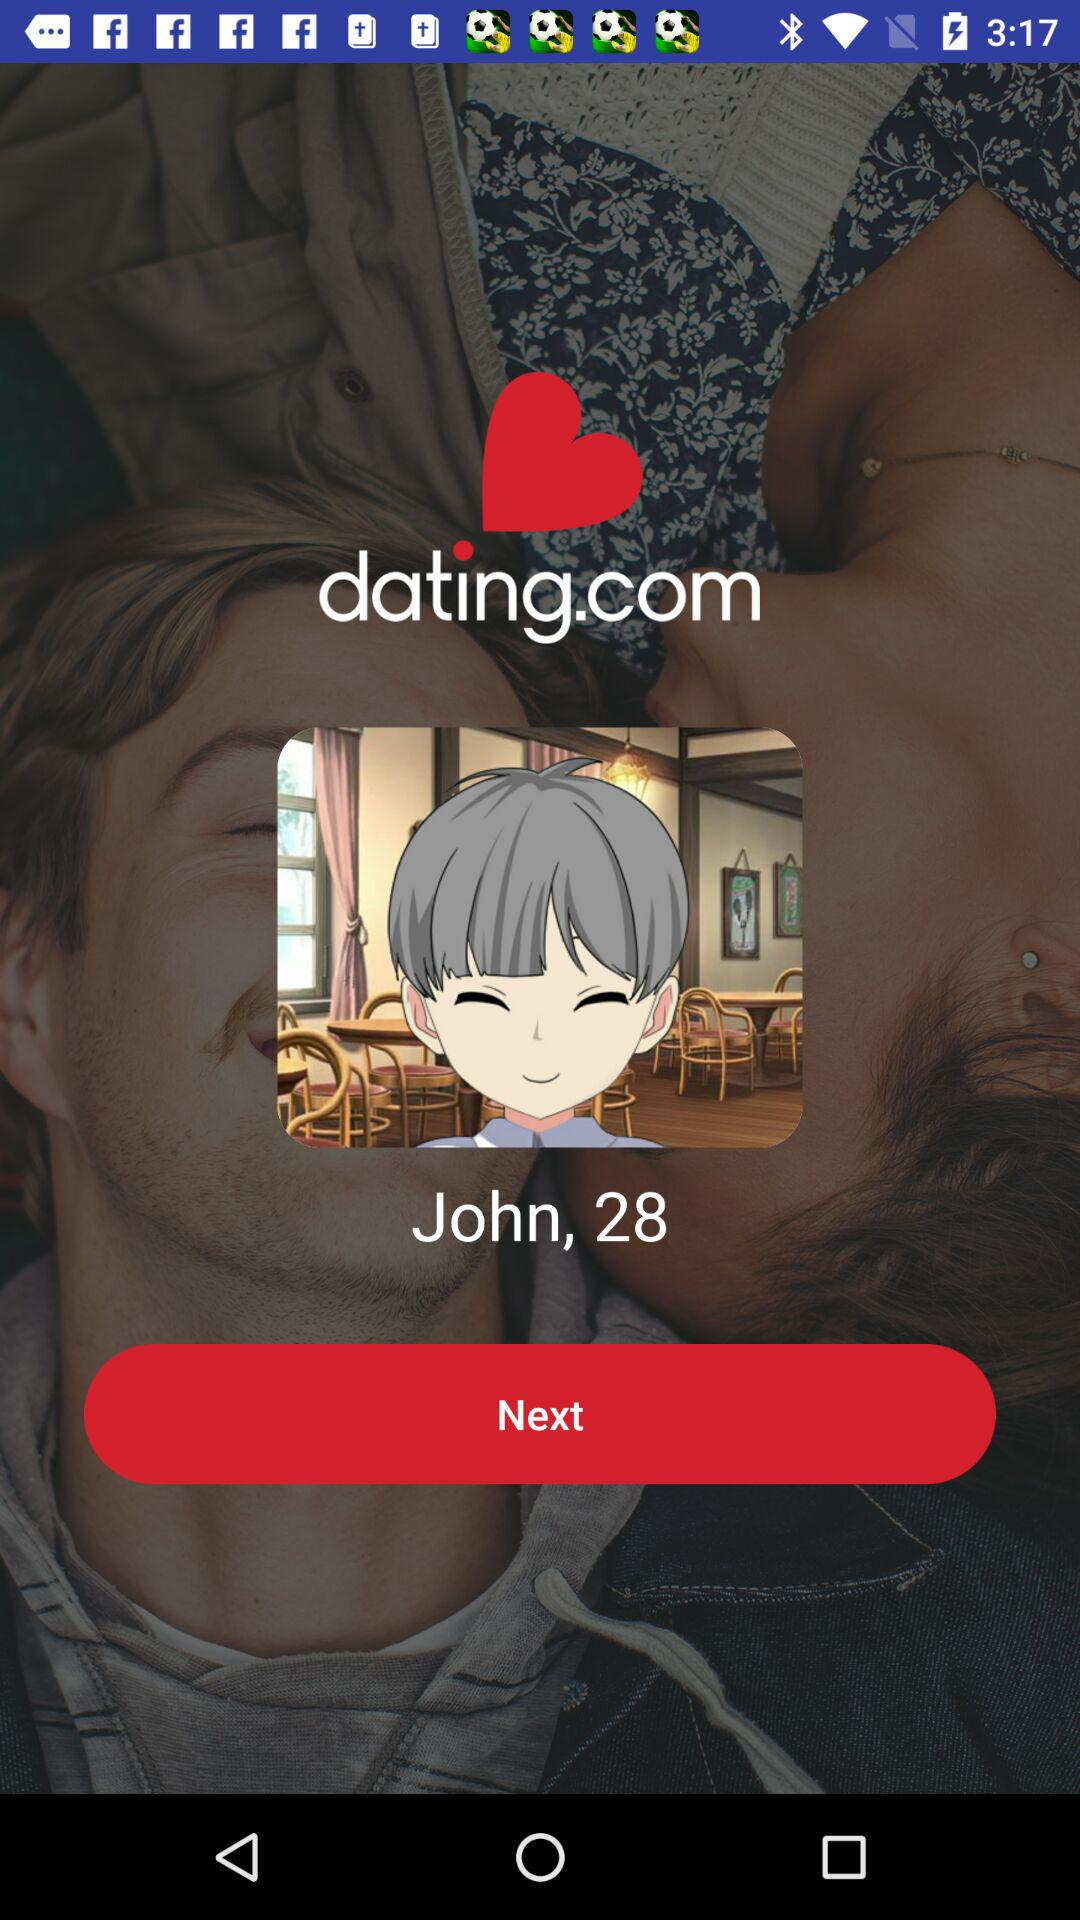What is the user name? The user name is John. 